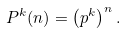Convert formula to latex. <formula><loc_0><loc_0><loc_500><loc_500>P ^ { k } ( n ) = \left ( p ^ { k } \right ) ^ { n } .</formula> 